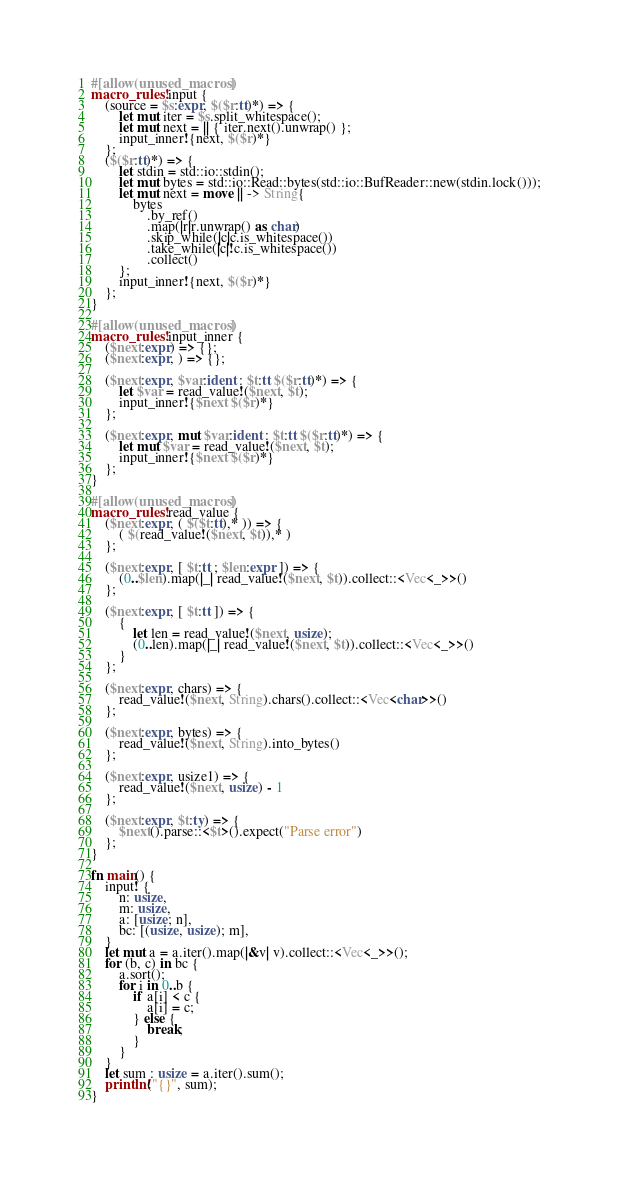Convert code to text. <code><loc_0><loc_0><loc_500><loc_500><_Rust_>#[allow(unused_macros)]
macro_rules! input {
    (source = $s:expr, $($r:tt)*) => {
        let mut iter = $s.split_whitespace();
        let mut next = || { iter.next().unwrap() };
        input_inner!{next, $($r)*}
    };
    ($($r:tt)*) => {
        let stdin = std::io::stdin();
        let mut bytes = std::io::Read::bytes(std::io::BufReader::new(stdin.lock()));
        let mut next = move || -> String{
            bytes
                .by_ref()
                .map(|r|r.unwrap() as char)
                .skip_while(|c|c.is_whitespace())
                .take_while(|c|!c.is_whitespace())
                .collect()
        };
        input_inner!{next, $($r)*}
    };
}

#[allow(unused_macros)]
macro_rules! input_inner {
    ($next:expr) => {};
    ($next:expr, ) => {};

    ($next:expr, $var:ident : $t:tt $($r:tt)*) => {
        let $var = read_value!($next, $t);
        input_inner!{$next $($r)*}
    };

    ($next:expr, mut $var:ident : $t:tt $($r:tt)*) => {
        let mut $var = read_value!($next, $t);
        input_inner!{$next $($r)*}
    };
}

#[allow(unused_macros)]
macro_rules! read_value {
    ($next:expr, ( $($t:tt),* )) => {
        ( $(read_value!($next, $t)),* )
    };

    ($next:expr, [ $t:tt ; $len:expr ]) => {
        (0..$len).map(|_| read_value!($next, $t)).collect::<Vec<_>>()
    };

    ($next:expr, [ $t:tt ]) => {
        {
            let len = read_value!($next, usize);
            (0..len).map(|_| read_value!($next, $t)).collect::<Vec<_>>()
        }
    };

    ($next:expr, chars) => {
        read_value!($next, String).chars().collect::<Vec<char>>()
    };

    ($next:expr, bytes) => {
        read_value!($next, String).into_bytes()
    };

    ($next:expr, usize1) => {
        read_value!($next, usize) - 1
    };

    ($next:expr, $t:ty) => {
        $next().parse::<$t>().expect("Parse error")
    };
}

fn main() {
    input! {
        n: usize,
        m: usize,
        a: [usize; n],
        bc: [(usize, usize); m],
    }
    let mut a = a.iter().map(|&v| v).collect::<Vec<_>>();
    for (b, c) in bc {
        a.sort();
        for i in 0..b {
            if a[i] < c {
                a[i] = c;
            } else {
                break;
            }
        }
    }
    let sum : usize = a.iter().sum();
    println!("{}", sum);
}
</code> 